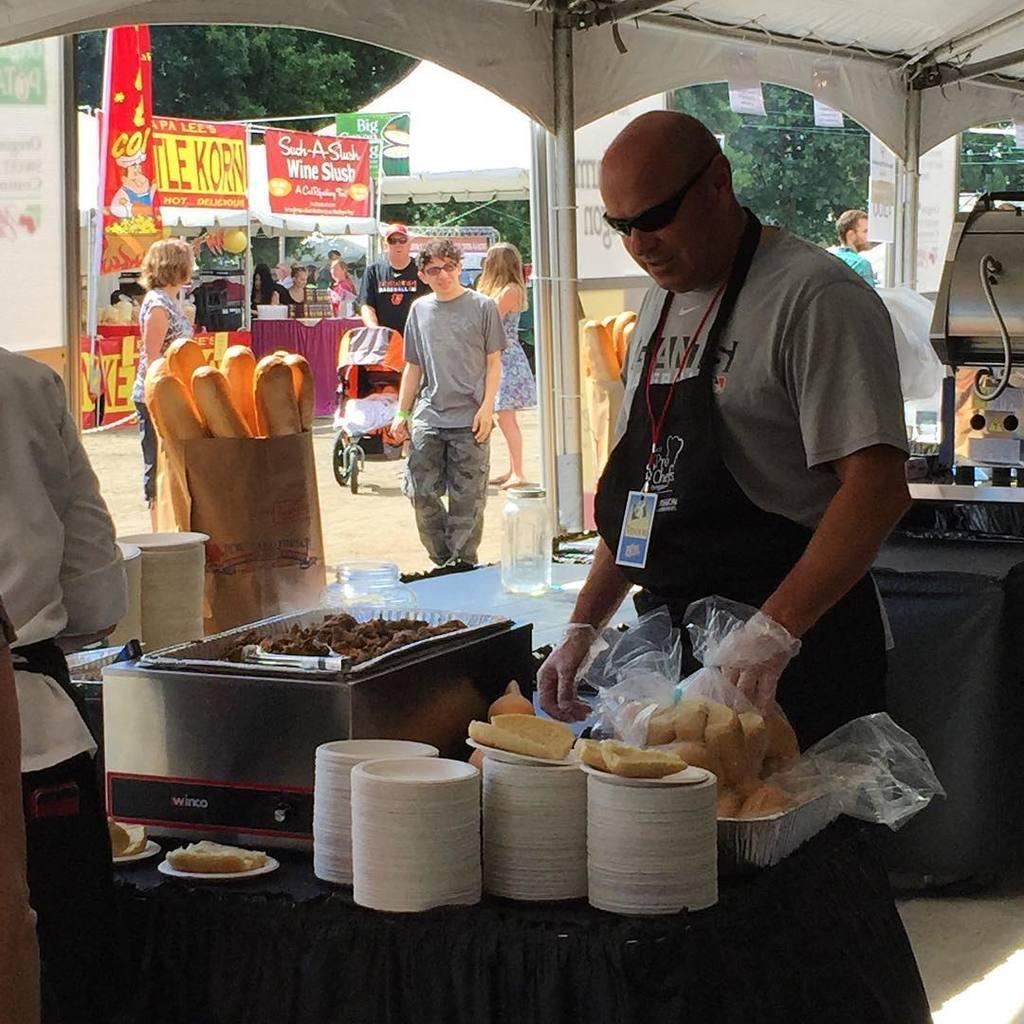Could you give a brief overview of what you see in this image? In this picture I can see there is a man standing here and he is wearing gloves and in the backdrop there are few people standing and one of them is holding the trolley and in the backdrop there are trees and plants. The sky is clear. 